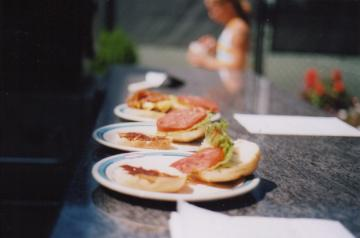Based on the information provided, deduce any complex reasoning-related information about the scene. It may be deduced that the image is depicting a lunchtime or snack scene, with various sandwich options on the plates, the kid next to the counter possibly waiting to eat, and an overall casual atmosphere. This implies a home or informal dining setting. Enumerate any visible colors and their corresponding objects in the scene. White - plates, kid's t-shirt, and papers; Red - tomato; Blue - part of a plate; Orange - flowers; Green - lettuce, small bush; Black - background element. Identify the primary focus of the image and describe its placement. The primary focus of the image is the food on the counter, specifically three plates of sandwiches, placed towards the center of the image. What is the most prominent feature in the scene? The most prominent feature is the three plates of sandwiches on the counter. What can you tell about the quality of the image based on the details provided? The image quality seems to be relatively clear, as there are numerous objects identified with specific positions and dimensions. Count the number of sandwiches and specify their location. There are three sandwiches located on the plates on the counter. Determine the overall sentiment or mood conveyed by the image. The overall sentiment is casual and relaxed, as it depicts a lunch scene with food prepared on the counter. List any non-food related items in the image and their locations. Kid wearing white tshirt at the top-left corner, orange flowers at the top-right corner, small green bush on the left side, white paper and bunch of papers on the counter, and background items such as black and girl walking across the back. Explain any objects or people interacting with each other in the image. A kid wearing a white t-shirt is standing next to the counter with the plates of sandwiches, possibly waiting to eat them. How many plates are on the counter and what do they contain? There are three white plates on the counter, each containing a sandwich with different ingredients such as lettuce and tomato. Can you see the purple flowers in the upper right corner? The flowers mentioned in the image are orange, not purple, and they are located in the corner but not specified as the upper right corner. Is a stack of blue papers lying on the counter? The image has information about the bunch of white papers on the counter, but no mention of any blue papers. Can you see the grey bird in the small green bush? There is a small green bush mentioned in the image, but there is no information about any bird in it. Are there four plates of sandwiches displayed on the counter? The image only mentions three plates of sandwiches, not four. Is there a green sandwich on one of the plates? The image only has information about burgers and no mention of a green sandwich. Is there a black dog next to the kid wearing a white t-shirt? There is a kid in a white t-shirt mentioned in the image, but there is no mention of a dog at all. 